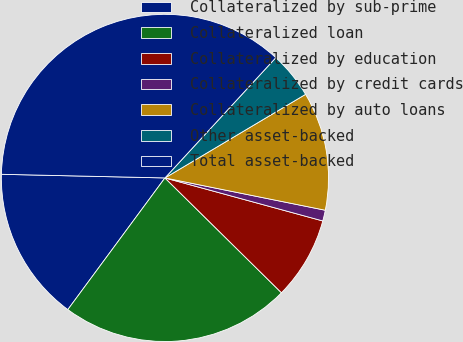Convert chart. <chart><loc_0><loc_0><loc_500><loc_500><pie_chart><fcel>Collateralized by sub-prime<fcel>Collateralized loan<fcel>Collateralized by education<fcel>Collateralized by credit cards<fcel>Collateralized by auto loans<fcel>Other asset-backed<fcel>Total asset-backed<nl><fcel>15.24%<fcel>22.73%<fcel>8.15%<fcel>1.07%<fcel>11.7%<fcel>4.61%<fcel>36.5%<nl></chart> 